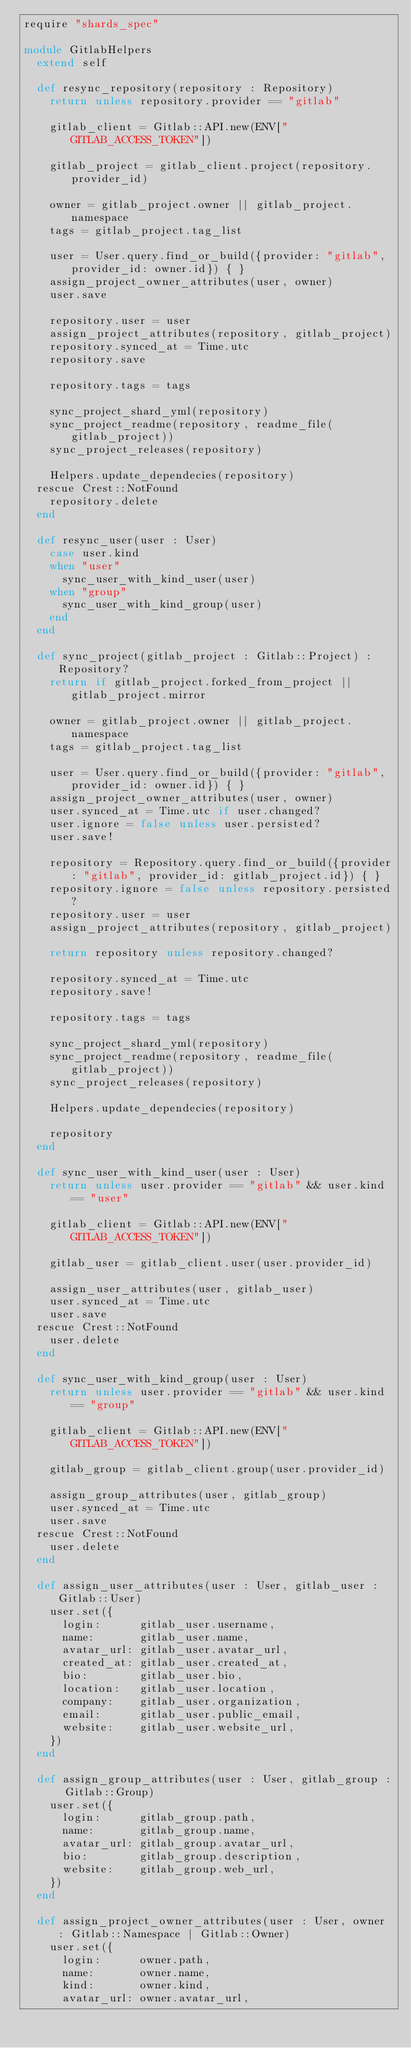<code> <loc_0><loc_0><loc_500><loc_500><_Crystal_>require "shards_spec"

module GitlabHelpers
  extend self

  def resync_repository(repository : Repository)
    return unless repository.provider == "gitlab"

    gitlab_client = Gitlab::API.new(ENV["GITLAB_ACCESS_TOKEN"])

    gitlab_project = gitlab_client.project(repository.provider_id)

    owner = gitlab_project.owner || gitlab_project.namespace
    tags = gitlab_project.tag_list

    user = User.query.find_or_build({provider: "gitlab", provider_id: owner.id}) { }
    assign_project_owner_attributes(user, owner)
    user.save

    repository.user = user
    assign_project_attributes(repository, gitlab_project)
    repository.synced_at = Time.utc
    repository.save

    repository.tags = tags

    sync_project_shard_yml(repository)
    sync_project_readme(repository, readme_file(gitlab_project))
    sync_project_releases(repository)

    Helpers.update_dependecies(repository)
  rescue Crest::NotFound
    repository.delete
  end

  def resync_user(user : User)
    case user.kind
    when "user"
      sync_user_with_kind_user(user)
    when "group"
      sync_user_with_kind_group(user)
    end
  end

  def sync_project(gitlab_project : Gitlab::Project) : Repository?
    return if gitlab_project.forked_from_project || gitlab_project.mirror

    owner = gitlab_project.owner || gitlab_project.namespace
    tags = gitlab_project.tag_list

    user = User.query.find_or_build({provider: "gitlab", provider_id: owner.id}) { }
    assign_project_owner_attributes(user, owner)
    user.synced_at = Time.utc if user.changed?
    user.ignore = false unless user.persisted?
    user.save!

    repository = Repository.query.find_or_build({provider: "gitlab", provider_id: gitlab_project.id}) { }
    repository.ignore = false unless repository.persisted?
    repository.user = user
    assign_project_attributes(repository, gitlab_project)

    return repository unless repository.changed?

    repository.synced_at = Time.utc
    repository.save!

    repository.tags = tags

    sync_project_shard_yml(repository)
    sync_project_readme(repository, readme_file(gitlab_project))
    sync_project_releases(repository)

    Helpers.update_dependecies(repository)

    repository
  end

  def sync_user_with_kind_user(user : User)
    return unless user.provider == "gitlab" && user.kind == "user"

    gitlab_client = Gitlab::API.new(ENV["GITLAB_ACCESS_TOKEN"])

    gitlab_user = gitlab_client.user(user.provider_id)

    assign_user_attributes(user, gitlab_user)
    user.synced_at = Time.utc
    user.save
  rescue Crest::NotFound
    user.delete
  end

  def sync_user_with_kind_group(user : User)
    return unless user.provider == "gitlab" && user.kind == "group"

    gitlab_client = Gitlab::API.new(ENV["GITLAB_ACCESS_TOKEN"])

    gitlab_group = gitlab_client.group(user.provider_id)

    assign_group_attributes(user, gitlab_group)
    user.synced_at = Time.utc
    user.save
  rescue Crest::NotFound
    user.delete
  end

  def assign_user_attributes(user : User, gitlab_user : Gitlab::User)
    user.set({
      login:      gitlab_user.username,
      name:       gitlab_user.name,
      avatar_url: gitlab_user.avatar_url,
      created_at: gitlab_user.created_at,
      bio:        gitlab_user.bio,
      location:   gitlab_user.location,
      company:    gitlab_user.organization,
      email:      gitlab_user.public_email,
      website:    gitlab_user.website_url,
    })
  end

  def assign_group_attributes(user : User, gitlab_group : Gitlab::Group)
    user.set({
      login:      gitlab_group.path,
      name:       gitlab_group.name,
      avatar_url: gitlab_group.avatar_url,
      bio:        gitlab_group.description,
      website:    gitlab_group.web_url,
    })
  end

  def assign_project_owner_attributes(user : User, owner : Gitlab::Namespace | Gitlab::Owner)
    user.set({
      login:      owner.path,
      name:       owner.name,
      kind:       owner.kind,
      avatar_url: owner.avatar_url,</code> 